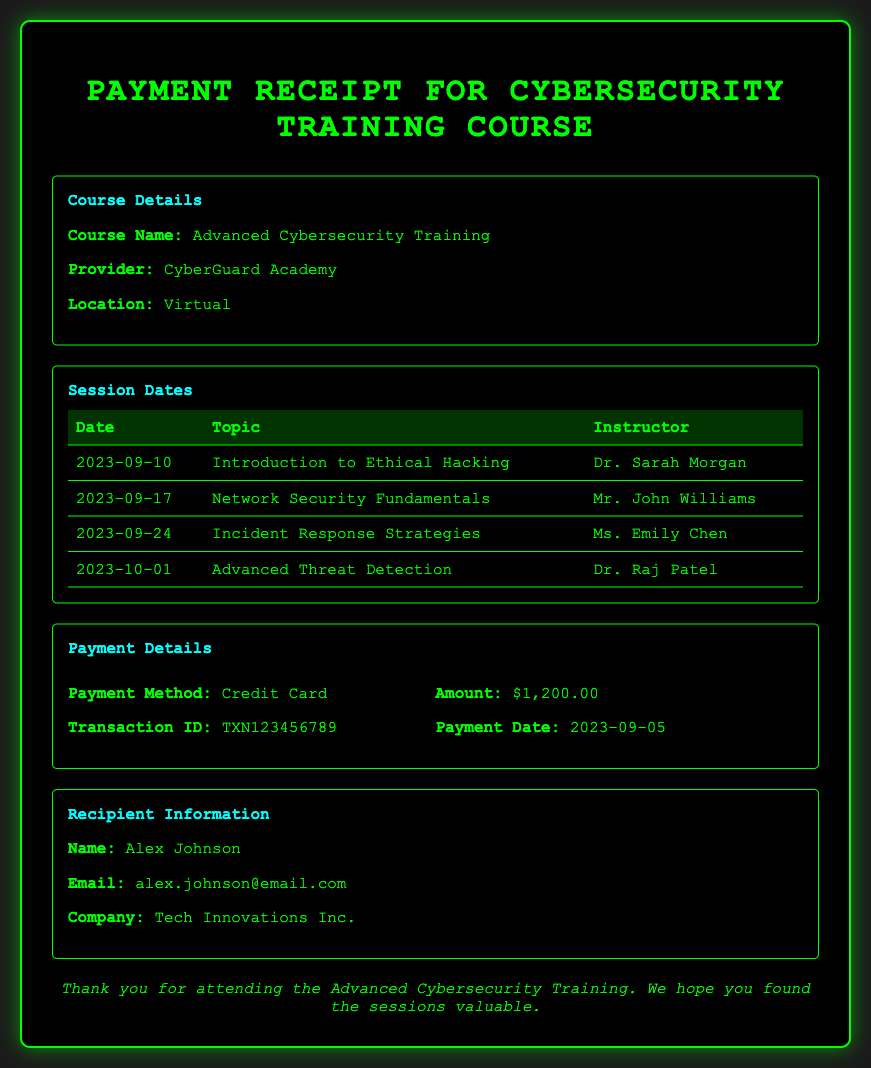What is the course name? The course name is explicitly mentioned in the document under Course Details.
Answer: Advanced Cybersecurity Training Who is the instructor for the session on September 24, 2023? This information can be found in the Session Dates section, which lists the instructors for each date.
Answer: Ms. Emily Chen What is the payment method used for the course? The payment method is stated in the Payment Details section of the document.
Answer: Credit Card How much did the training course cost? The amount paid is clearly indicated in the Payment Details section.
Answer: $1,200.00 On what date was the payment made? The payment date is specified in the Payment Details section.
Answer: 2023-09-05 How many sessions are there in total? The total number of sessions can be counted from the Session Dates table in the document.
Answer: 4 What is the name of the course provider? The provider's name is listed under Course Details in the document.
Answer: CyberGuard Academy What email address is associated with the recipient? The recipient's email address is found in the Recipient Information section.
Answer: alex.johnson@email.com What is the transaction ID for the payment? The transaction ID is provided in the Payment Details section.
Answer: TXN123456789 